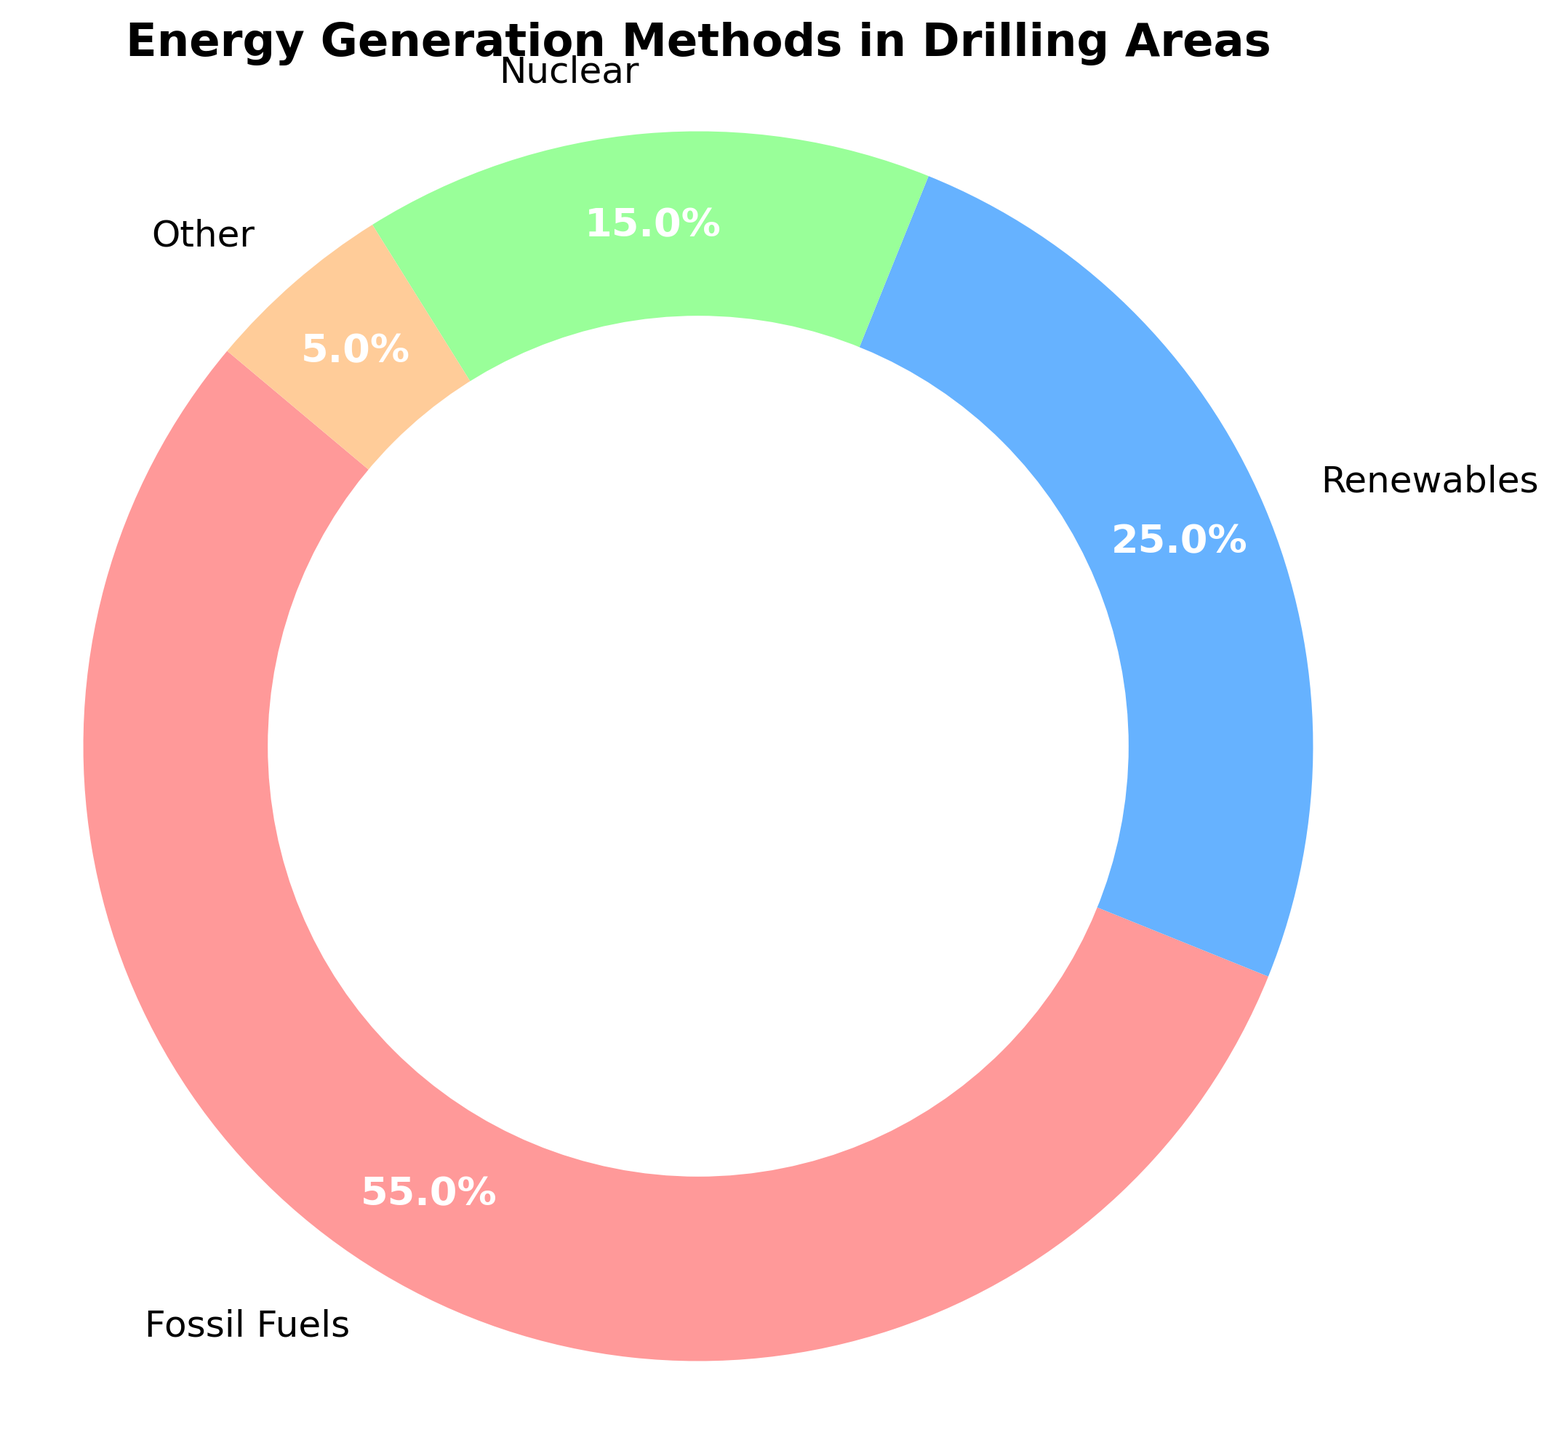What energy generation method has the highest percentage in areas with drilling activities? Observing the pie chart, the segment with the largest size represents the highest percentage. The label for this segment indicates it corresponds to "Fossil Fuels" with 55%.
Answer: Fossil Fuels Which two energy generation methods combined make up the smallest share? To determine this, we need to add up the percentages of various combinations and compare. The percentages for "Nuclear" and "Other" together are 15% + 5% = 20%, which is the smallest combined share.
Answer: Nuclear and Other How much larger in percentage is the category "Fossil Fuels" compared to "Renewables"? Subtract the percentage of "Renewables" from "Fossil Fuels": 55% - 25% = 30%.
Answer: 30% What percentage of energy generation methods are non-fossil fuels in areas with drilling activities? Adding up the percentages for "Renewables", "Nuclear", and "Other", which are all non-fossil fuel categories: 25% + 15% + 5% = 45%.
Answer: 45% Which segment on the pie chart is colored green and what is its percentage share? Observing the segment colors on the pie chart: the green segment corresponds to "Renewables" and is labeled with 25%.
Answer: Renewables with 25% If the "Other" category increased by 10%, what would the new percentage be for this category? Adding 10% to the current "Other" percentage: 5% + 10% = 15%.
Answer: 15% Which energy generation method is least utilized in areas with drilling activities? The least utilized method can be found by identifying the smallest segment on the pie chart, which corresponds to "Other" with 5%.
Answer: Other Compare the combined percentage of "Nuclear" and "Renewables" with "Fossil Fuels". Is the combined percentage larger or smaller? Adding the percentages of "Nuclear" and "Renewables": 15% + 25% = 40%. Comparing this to the "Fossil Fuels" percentage of 55%, we see that 40% is smaller.
Answer: Smaller How much more is the percentage of "Fossil Fuels" than the sum of "Nuclear" and "Other"? Calculate the sum of "Nuclear" and "Other": 15% + 5% = 20%. Then find the difference with "Fossil Fuels": 55% - 20% = 35%.
Answer: 35% 